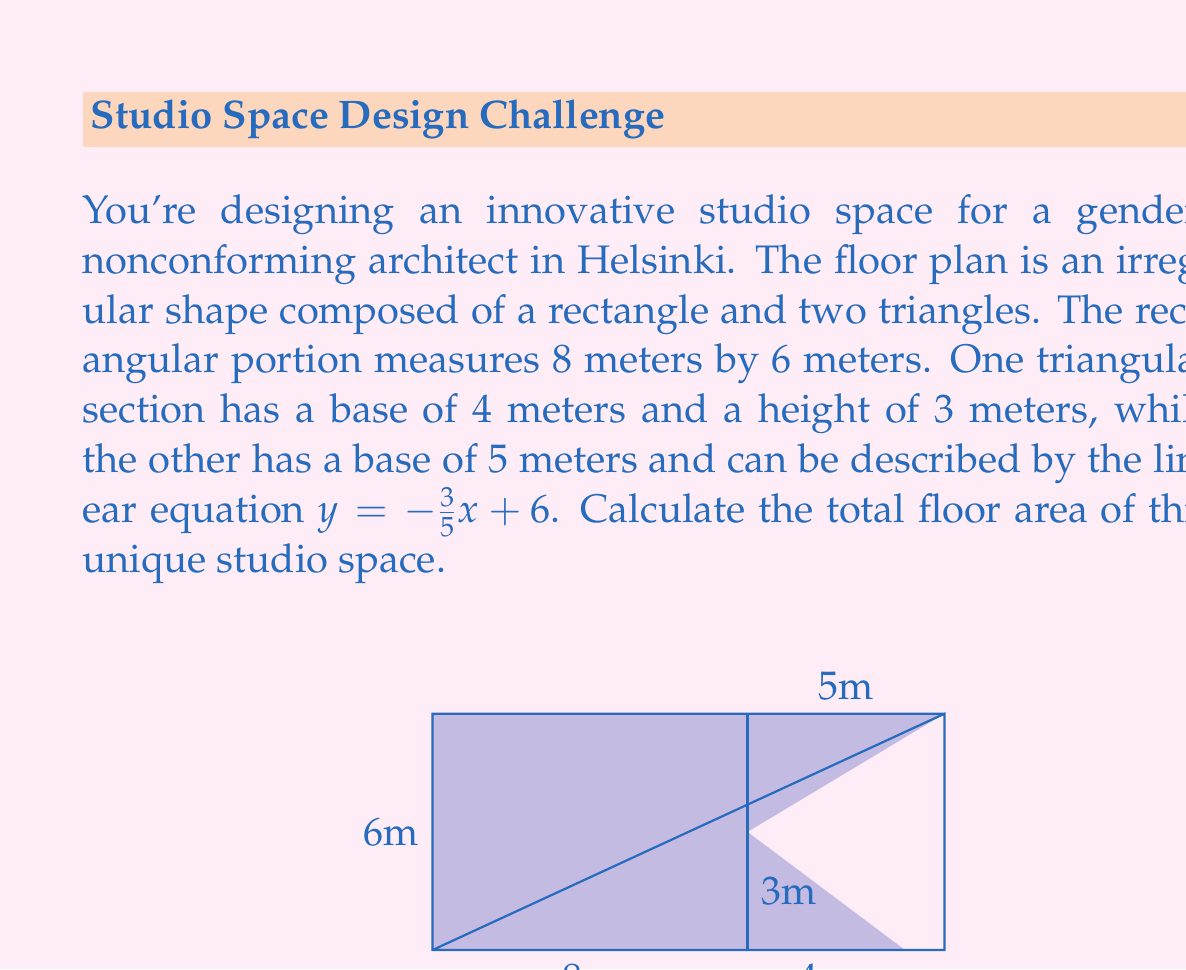Help me with this question. Let's break this problem down into steps:

1) First, calculate the area of the rectangular portion:
   $$A_{rectangle} = 8 \times 6 = 48 \text{ m}^2$$

2) Next, calculate the area of the first triangle:
   $$A_{triangle1} = \frac{1}{2} \times 4 \times 3 = 6 \text{ m}^2$$

3) For the second triangle, we need to find its height using the given equation:
   $y = -\frac{3}{5}x + 6$
   When $x = 5$ (the base of the triangle), $y = 0$:
   $$0 = -\frac{3}{5}(5) + 6$$
   $$0 = -3 + 6$$
   $$3 = 3$$
   So the height of this triangle is 3 meters.

4) Calculate the area of the second triangle:
   $$A_{triangle2} = \frac{1}{2} \times 5 \times 3 = 7.5 \text{ m}^2$$

5) Sum up all the areas:
   $$A_{total} = A_{rectangle} + A_{triangle1} + A_{triangle2}$$
   $$A_{total} = 48 + 6 + 7.5 = 61.5 \text{ m}^2$$

Therefore, the total floor area of the studio space is 61.5 square meters.
Answer: 61.5 m² 